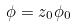Convert formula to latex. <formula><loc_0><loc_0><loc_500><loc_500>\phi = z _ { 0 } \phi _ { 0 }</formula> 